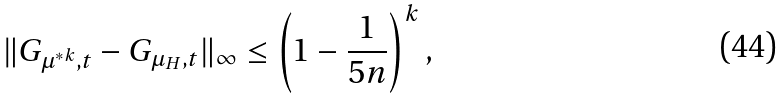Convert formula to latex. <formula><loc_0><loc_0><loc_500><loc_500>\| G _ { \mu ^ { * k } , t } - G _ { \mu _ { H } , t } \| _ { \infty } \leq \left ( 1 - \frac { 1 } { 5 n } \right ) ^ { k } ,</formula> 